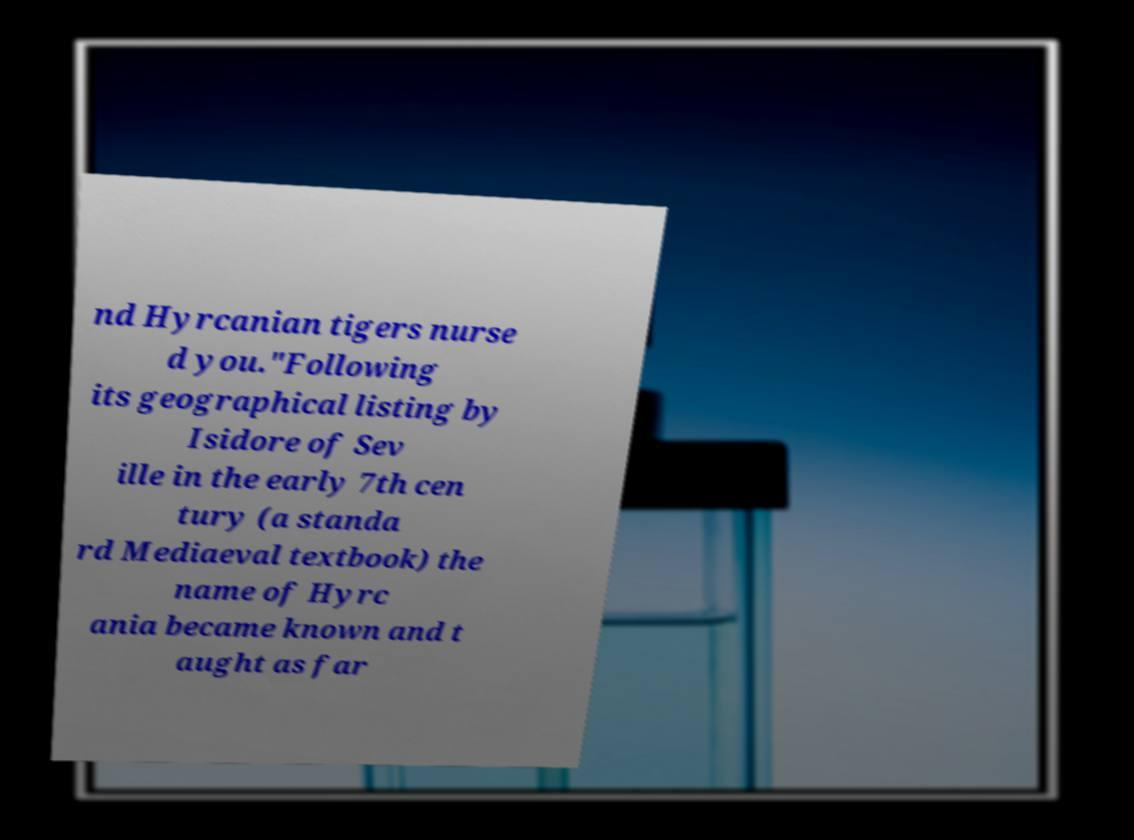Please read and relay the text visible in this image. What does it say? nd Hyrcanian tigers nurse d you."Following its geographical listing by Isidore of Sev ille in the early 7th cen tury (a standa rd Mediaeval textbook) the name of Hyrc ania became known and t aught as far 